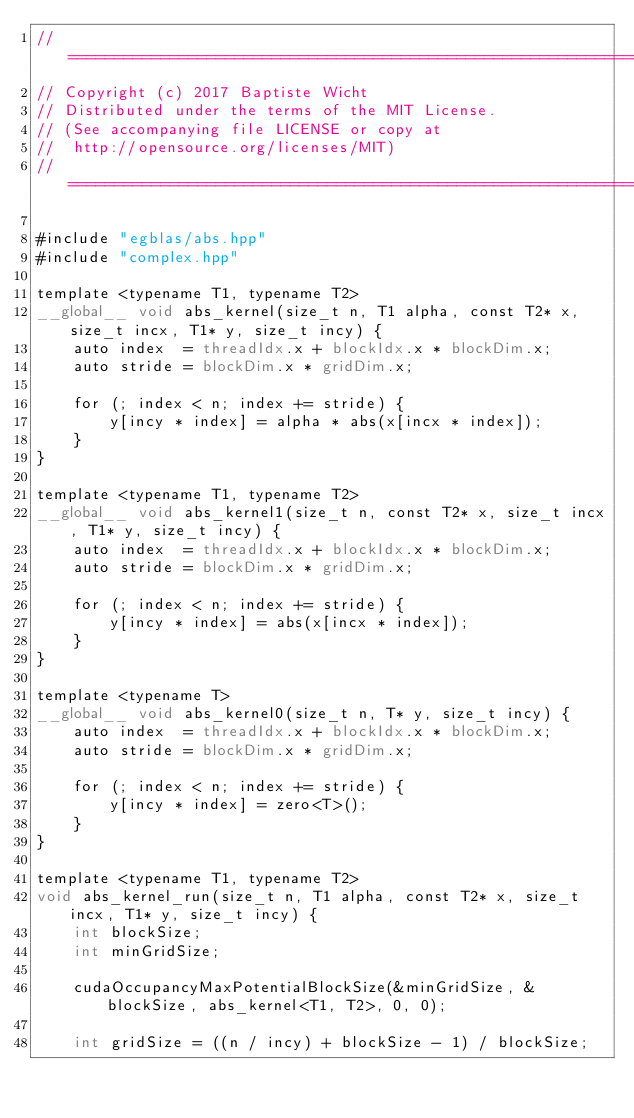<code> <loc_0><loc_0><loc_500><loc_500><_Cuda_>//=======================================================================
// Copyright (c) 2017 Baptiste Wicht
// Distributed under the terms of the MIT License.
// (See accompanying file LICENSE or copy at
//  http://opensource.org/licenses/MIT)
//=======================================================================

#include "egblas/abs.hpp"
#include "complex.hpp"

template <typename T1, typename T2>
__global__ void abs_kernel(size_t n, T1 alpha, const T2* x, size_t incx, T1* y, size_t incy) {
    auto index  = threadIdx.x + blockIdx.x * blockDim.x;
    auto stride = blockDim.x * gridDim.x;

    for (; index < n; index += stride) {
        y[incy * index] = alpha * abs(x[incx * index]);
    }
}

template <typename T1, typename T2>
__global__ void abs_kernel1(size_t n, const T2* x, size_t incx, T1* y, size_t incy) {
    auto index  = threadIdx.x + blockIdx.x * blockDim.x;
    auto stride = blockDim.x * gridDim.x;

    for (; index < n; index += stride) {
        y[incy * index] = abs(x[incx * index]);
    }
}

template <typename T>
__global__ void abs_kernel0(size_t n, T* y, size_t incy) {
    auto index  = threadIdx.x + blockIdx.x * blockDim.x;
    auto stride = blockDim.x * gridDim.x;

    for (; index < n; index += stride) {
        y[incy * index] = zero<T>();
    }
}

template <typename T1, typename T2>
void abs_kernel_run(size_t n, T1 alpha, const T2* x, size_t incx, T1* y, size_t incy) {
    int blockSize;
    int minGridSize;

    cudaOccupancyMaxPotentialBlockSize(&minGridSize, &blockSize, abs_kernel<T1, T2>, 0, 0);

    int gridSize = ((n / incy) + blockSize - 1) / blockSize;
</code> 